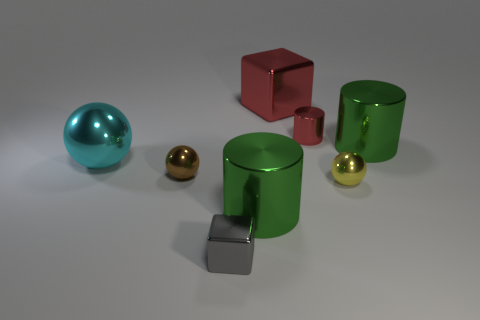How many things are either objects behind the small gray block or tiny red metal cubes? Examining the image, we can identify a total of four objects situated behind the small gray block — one spherical teal object, two cylindrical green containers, and one small golden sphere. In addition, there is one tiny red metal cube. Together, these add up to five objects in total that fit the criteria. 